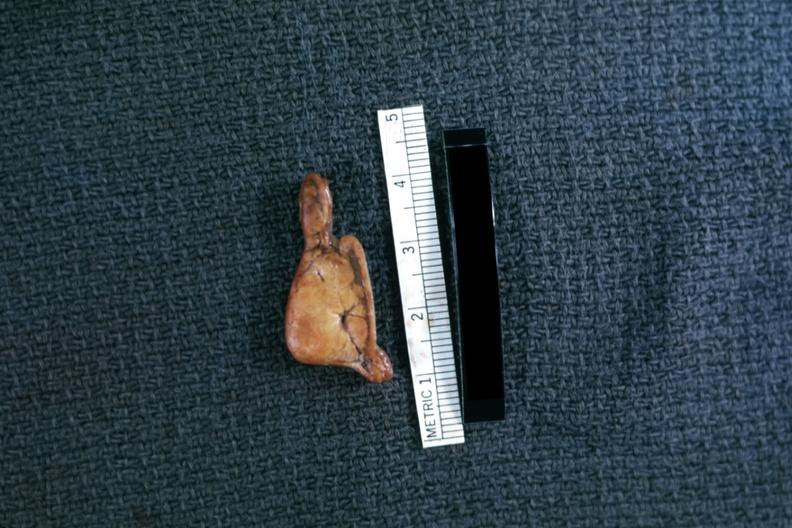what is present?
Answer the question using a single word or phrase. Endocrine 